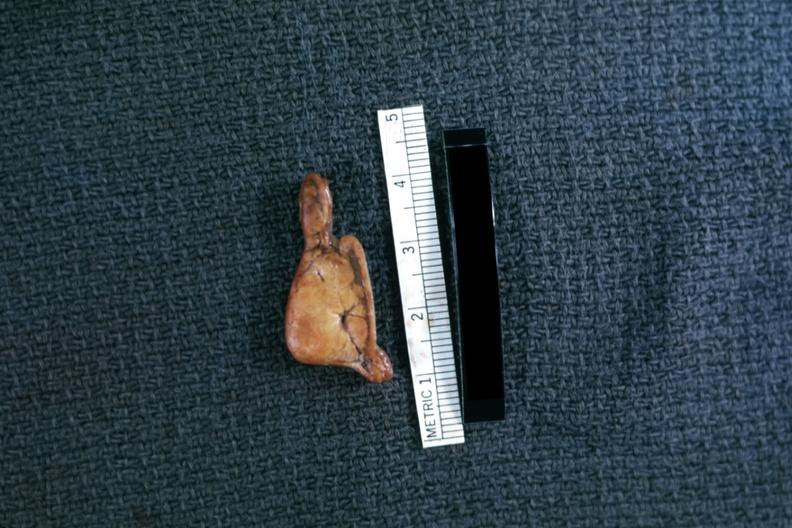what is present?
Answer the question using a single word or phrase. Endocrine 